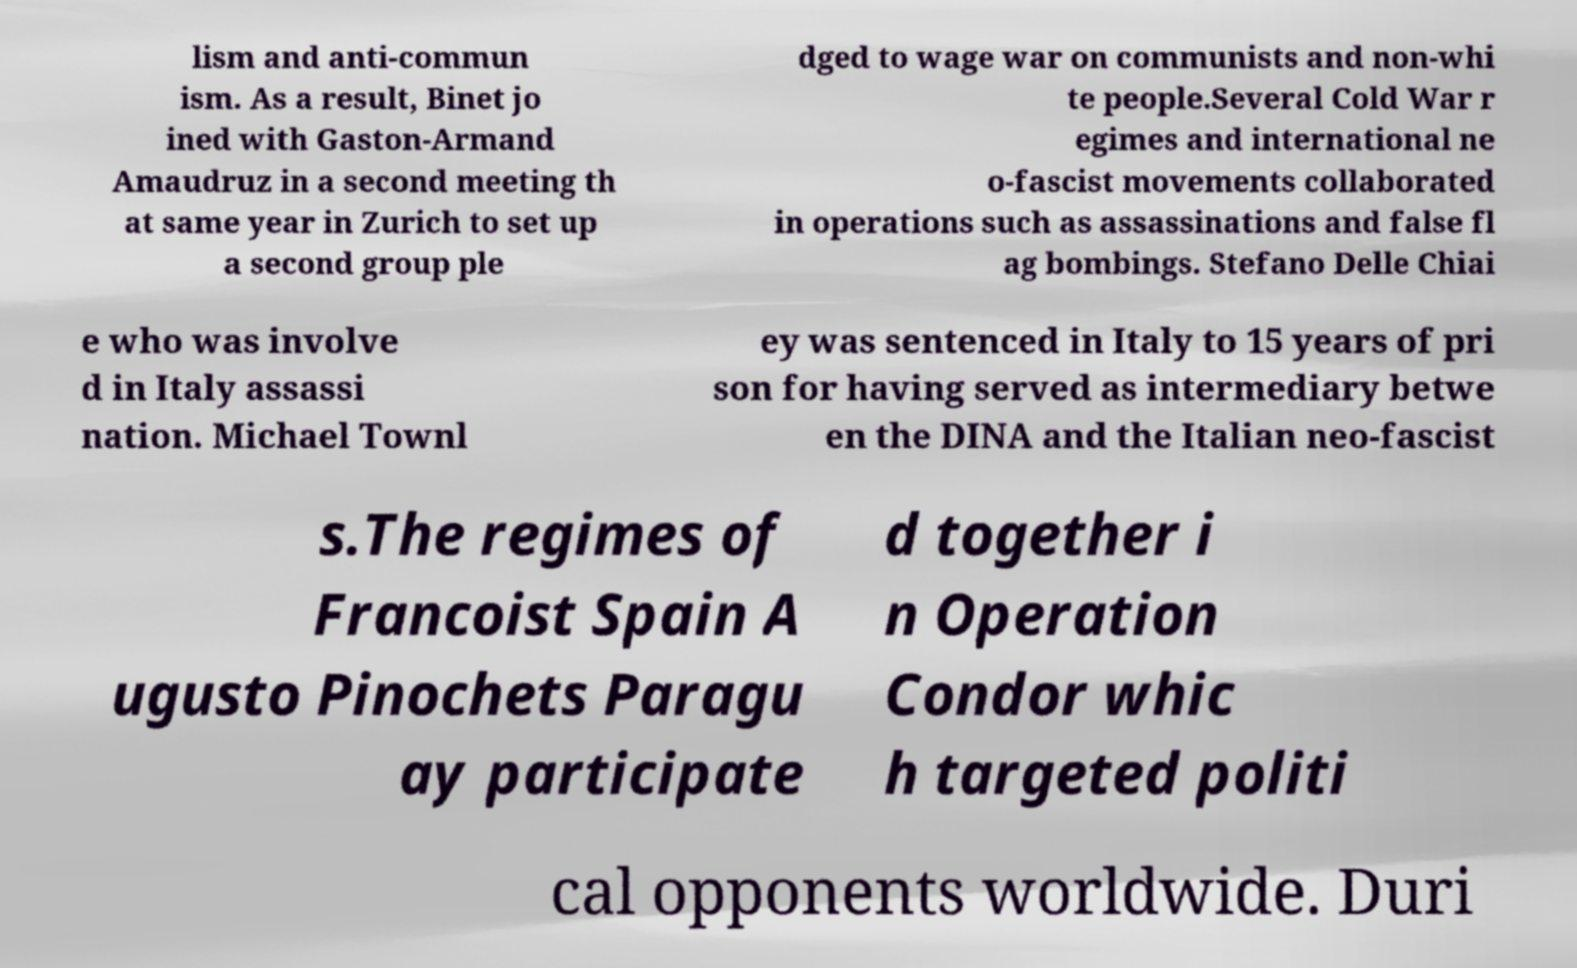Please read and relay the text visible in this image. What does it say? lism and anti-commun ism. As a result, Binet jo ined with Gaston-Armand Amaudruz in a second meeting th at same year in Zurich to set up a second group ple dged to wage war on communists and non-whi te people.Several Cold War r egimes and international ne o-fascist movements collaborated in operations such as assassinations and false fl ag bombings. Stefano Delle Chiai e who was involve d in Italy assassi nation. Michael Townl ey was sentenced in Italy to 15 years of pri son for having served as intermediary betwe en the DINA and the Italian neo-fascist s.The regimes of Francoist Spain A ugusto Pinochets Paragu ay participate d together i n Operation Condor whic h targeted politi cal opponents worldwide. Duri 